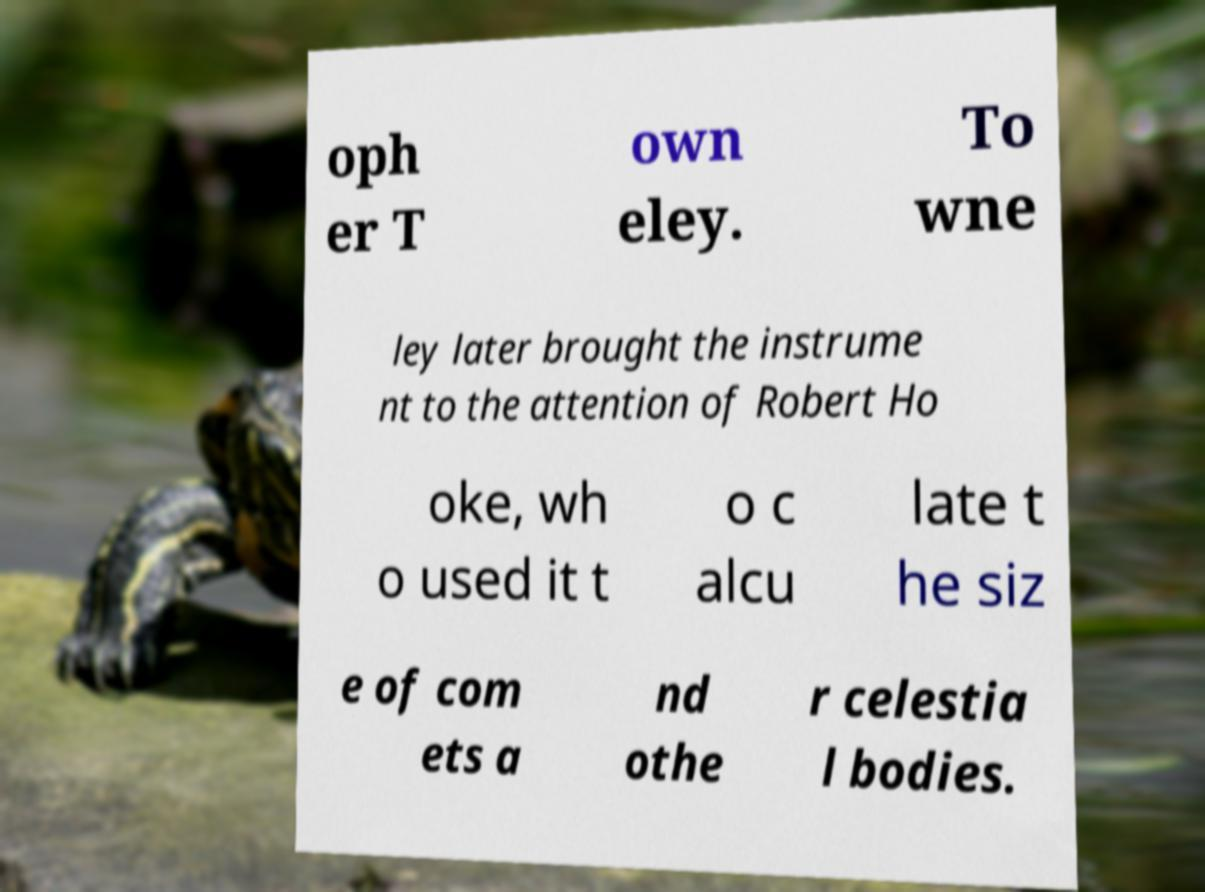Could you assist in decoding the text presented in this image and type it out clearly? oph er T own eley. To wne ley later brought the instrume nt to the attention of Robert Ho oke, wh o used it t o c alcu late t he siz e of com ets a nd othe r celestia l bodies. 